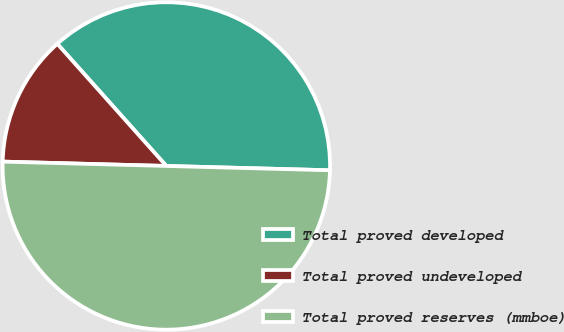<chart> <loc_0><loc_0><loc_500><loc_500><pie_chart><fcel>Total proved developed<fcel>Total proved undeveloped<fcel>Total proved reserves (mmboe)<nl><fcel>37.02%<fcel>12.98%<fcel>50.0%<nl></chart> 